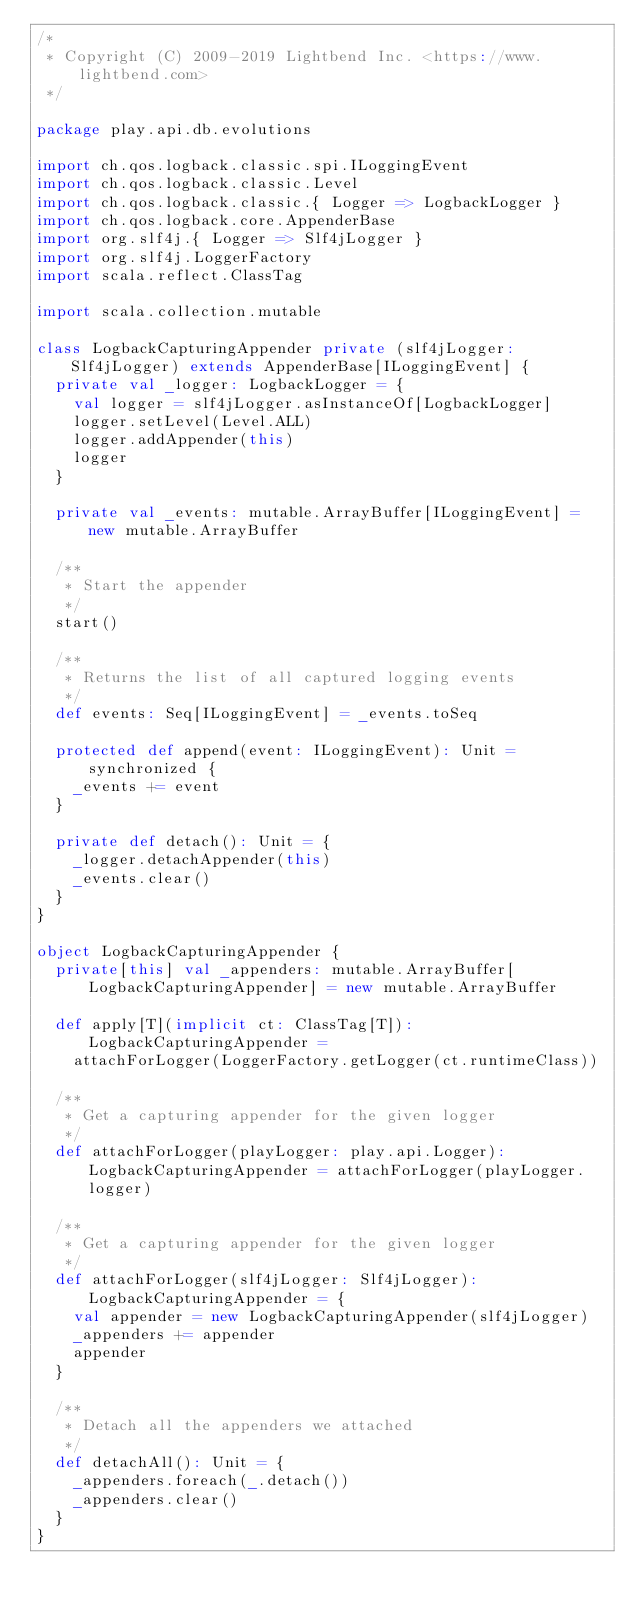<code> <loc_0><loc_0><loc_500><loc_500><_Scala_>/*
 * Copyright (C) 2009-2019 Lightbend Inc. <https://www.lightbend.com>
 */

package play.api.db.evolutions

import ch.qos.logback.classic.spi.ILoggingEvent
import ch.qos.logback.classic.Level
import ch.qos.logback.classic.{ Logger => LogbackLogger }
import ch.qos.logback.core.AppenderBase
import org.slf4j.{ Logger => Slf4jLogger }
import org.slf4j.LoggerFactory
import scala.reflect.ClassTag

import scala.collection.mutable

class LogbackCapturingAppender private (slf4jLogger: Slf4jLogger) extends AppenderBase[ILoggingEvent] {
  private val _logger: LogbackLogger = {
    val logger = slf4jLogger.asInstanceOf[LogbackLogger]
    logger.setLevel(Level.ALL)
    logger.addAppender(this)
    logger
  }

  private val _events: mutable.ArrayBuffer[ILoggingEvent] = new mutable.ArrayBuffer

  /**
   * Start the appender
   */
  start()

  /**
   * Returns the list of all captured logging events
   */
  def events: Seq[ILoggingEvent] = _events.toSeq

  protected def append(event: ILoggingEvent): Unit = synchronized {
    _events += event
  }

  private def detach(): Unit = {
    _logger.detachAppender(this)
    _events.clear()
  }
}

object LogbackCapturingAppender {
  private[this] val _appenders: mutable.ArrayBuffer[LogbackCapturingAppender] = new mutable.ArrayBuffer

  def apply[T](implicit ct: ClassTag[T]): LogbackCapturingAppender =
    attachForLogger(LoggerFactory.getLogger(ct.runtimeClass))

  /**
   * Get a capturing appender for the given logger
   */
  def attachForLogger(playLogger: play.api.Logger): LogbackCapturingAppender = attachForLogger(playLogger.logger)

  /**
   * Get a capturing appender for the given logger
   */
  def attachForLogger(slf4jLogger: Slf4jLogger): LogbackCapturingAppender = {
    val appender = new LogbackCapturingAppender(slf4jLogger)
    _appenders += appender
    appender
  }

  /**
   * Detach all the appenders we attached
   */
  def detachAll(): Unit = {
    _appenders.foreach(_.detach())
    _appenders.clear()
  }
}
</code> 